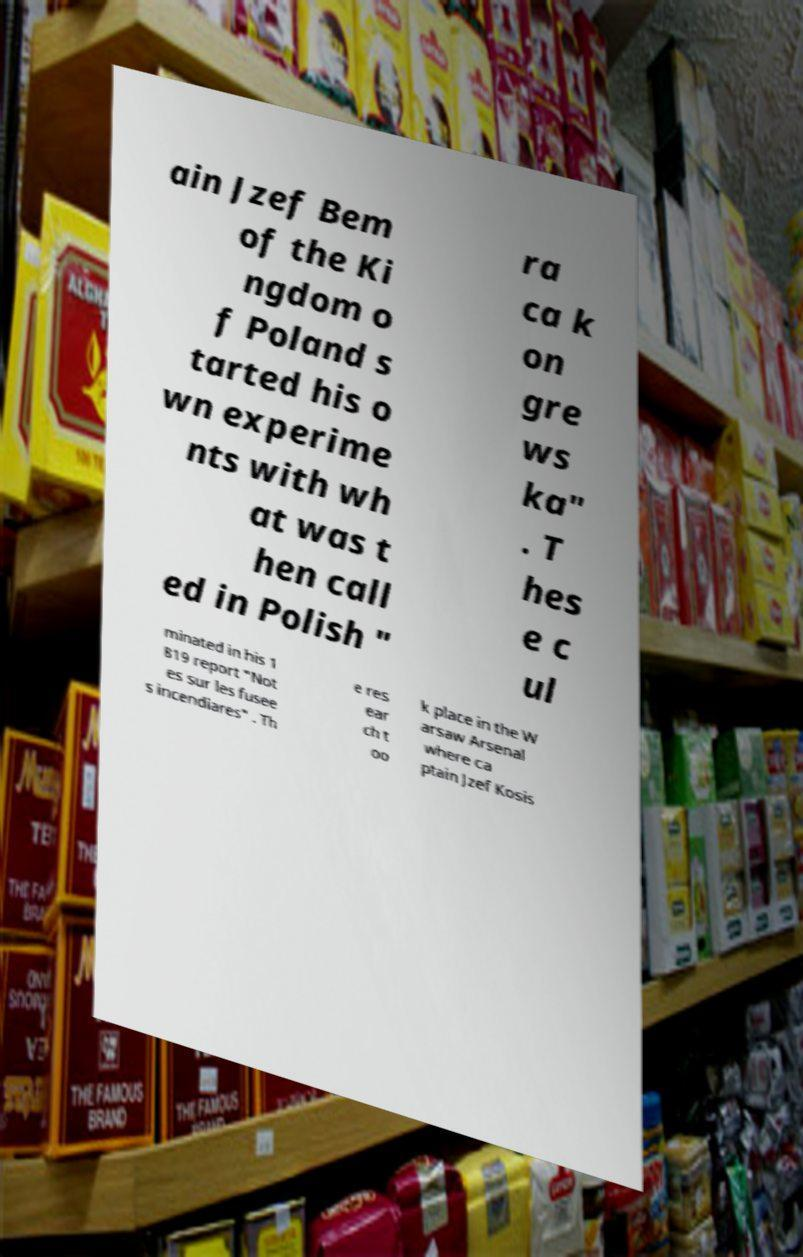For documentation purposes, I need the text within this image transcribed. Could you provide that? ain Jzef Bem of the Ki ngdom o f Poland s tarted his o wn experime nts with wh at was t hen call ed in Polish " ra ca k on gre ws ka" . T hes e c ul minated in his 1 819 report "Not es sur les fusee s incendiares" . Th e res ear ch t oo k place in the W arsaw Arsenal where ca ptain Jzef Kosis 